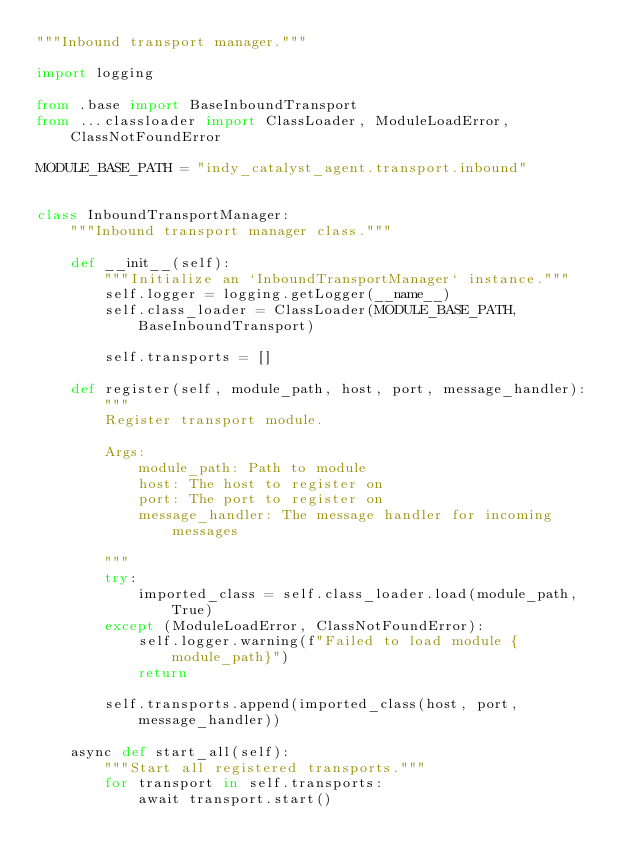Convert code to text. <code><loc_0><loc_0><loc_500><loc_500><_Python_>"""Inbound transport manager."""

import logging

from .base import BaseInboundTransport
from ...classloader import ClassLoader, ModuleLoadError, ClassNotFoundError

MODULE_BASE_PATH = "indy_catalyst_agent.transport.inbound"


class InboundTransportManager:
    """Inbound transport manager class."""

    def __init__(self):
        """Initialize an `InboundTransportManager` instance."""
        self.logger = logging.getLogger(__name__)
        self.class_loader = ClassLoader(MODULE_BASE_PATH, BaseInboundTransport)

        self.transports = []

    def register(self, module_path, host, port, message_handler):
        """
        Register transport module.

        Args:
            module_path: Path to module
            host: The host to register on
            port: The port to register on
            message_handler: The message handler for incoming messages

        """
        try:
            imported_class = self.class_loader.load(module_path, True)
        except (ModuleLoadError, ClassNotFoundError):
            self.logger.warning(f"Failed to load module {module_path}")
            return

        self.transports.append(imported_class(host, port, message_handler))

    async def start_all(self):
        """Start all registered transports."""
        for transport in self.transports:
            await transport.start()
</code> 